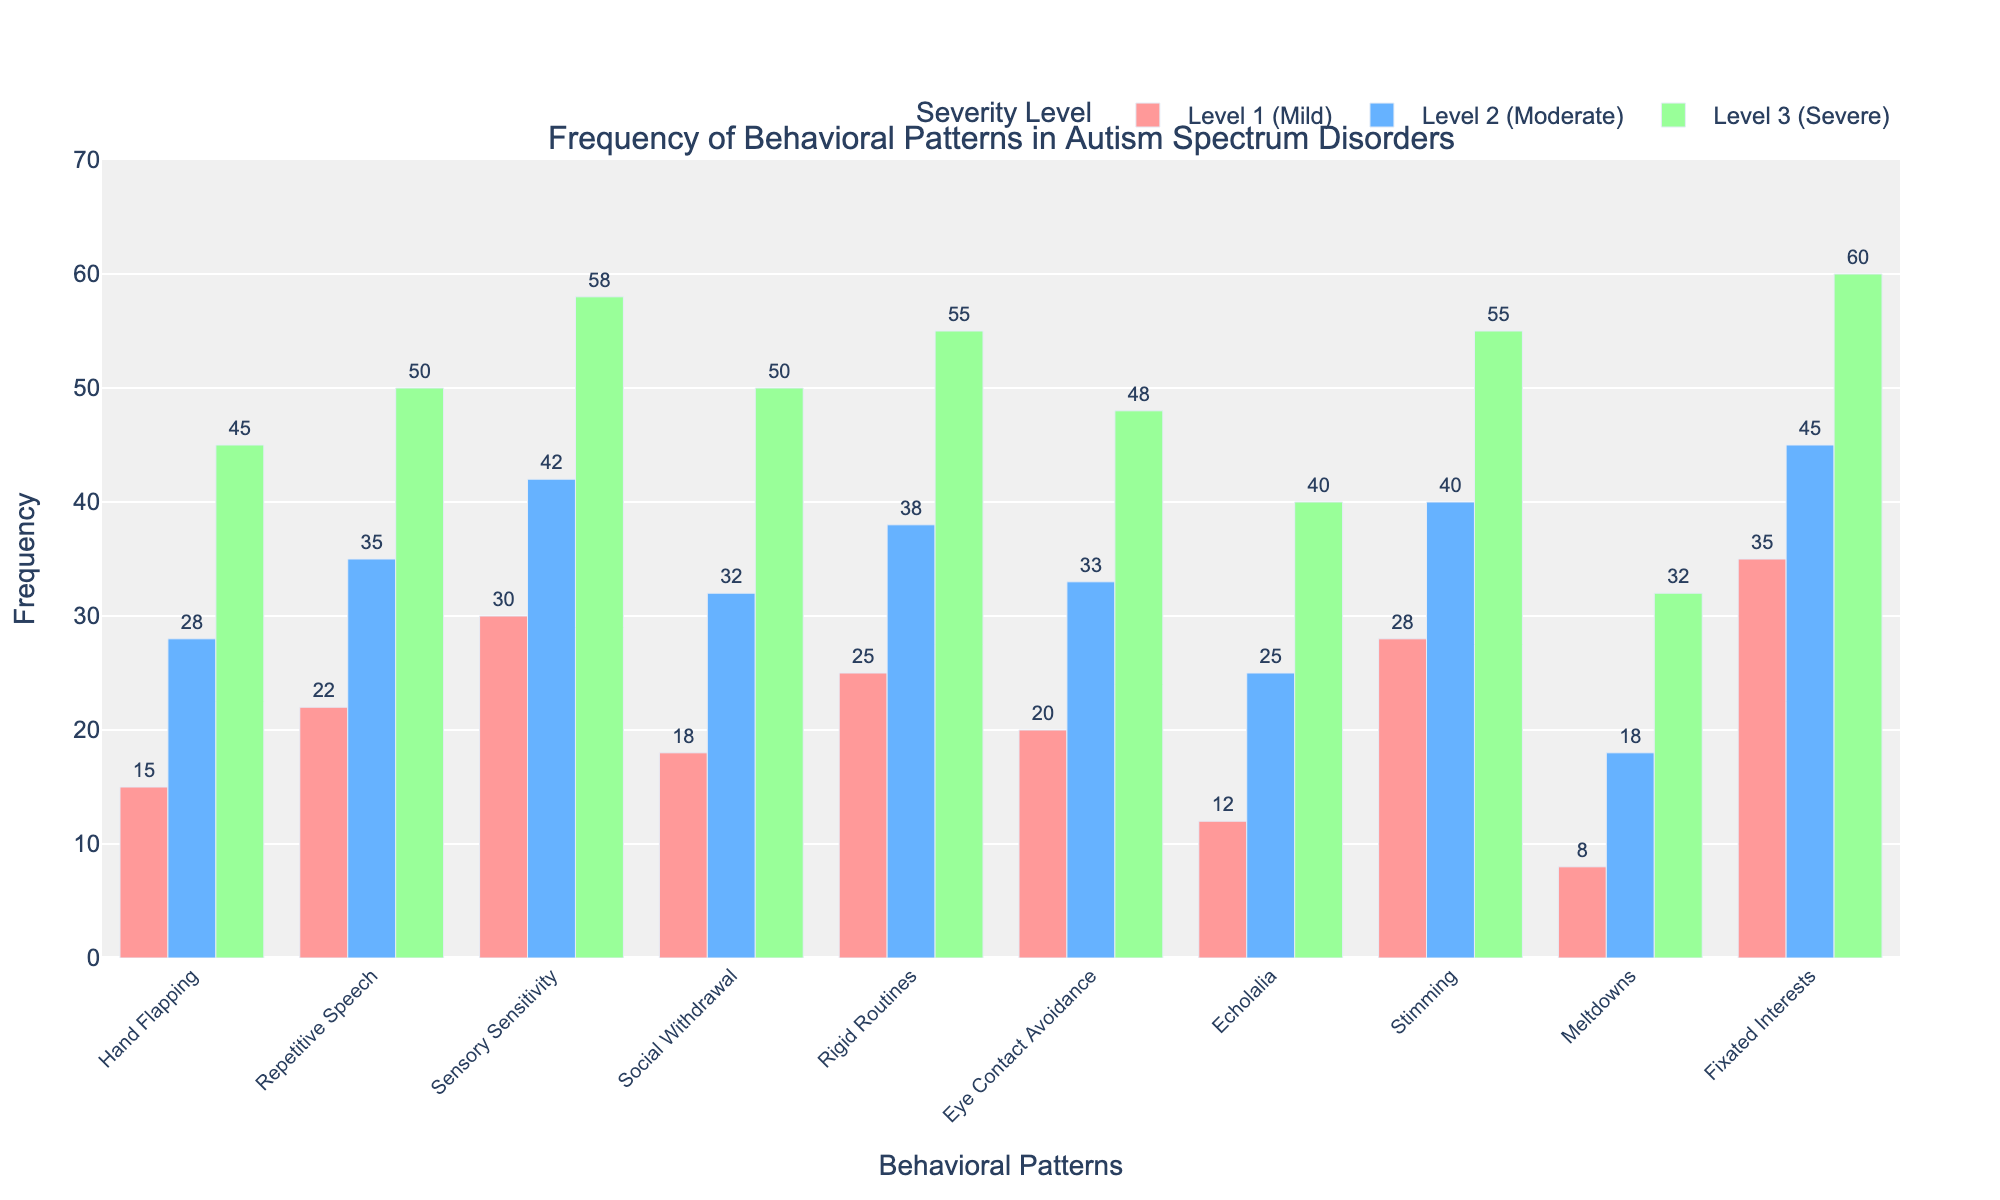What is the most frequent behavioral pattern observed at Level 2 (Moderate) severity? To find the most frequent behavioral pattern observed at Level 2, look at the highest value in the bar corresponding to "Level 2 (Moderate)." The highest bar is at 45 for "Fixated Interests."
Answer: Fixated Interests How much more frequent is "Social Withdrawal" in Level 3 (Severe) compared to Level 1 (Mild)? To find the difference, subtract the frequency of "Social Withdrawal" at Level 1 (18) from its frequency at Level 3 (50). The difference is 50 - 18 = 32.
Answer: 32 Which severity level has the highest frequency of "Echolalia"? Look at the bars corresponding to "Echolalia" for each severity level. The highest bar is at 40 for Level 3 (Severe).
Answer: Level 3 What's the average frequency of "Hand Flapping" across all severity levels? First, sum the frequencies for "Hand Flapping" across all levels: 15 (Mild) + 28 (Moderate) + 45 (Severe) = 88. Then, divide by the total number of levels (3): 88 / 3 ≈ 29.33.
Answer: 29.33 By how much does "Rigid Routines" differ between Level 2 (Moderate) and Level 3 (Severe)? To find the difference, subtract the frequency of "Rigid Routines" at Level 2 (38) from its frequency at Level 3 (55). The difference is 55 - 38 = 17.
Answer: 17 Which behavioral pattern shows the least difference in frequency between Level 1 (Mild) and Level 2 (Moderate)? Compare the differences for all patterns between Level 1 and Level 2, then find the smallest difference. "Echolalia" has the smallest difference: 25 - 12 = 13.
Answer: Echolalia What is the total frequency of "Stimming" observed across all severity levels? Add up the frequencies of "Stimming" for all levels: 28 (Mild) + 40 (Moderate) + 55 (Severe) = 123.
Answer: 123 Is "Meltdowns" more frequent in Level 2 (Moderate) or Level 1 (Mild)? Compare the heights of the bars for "Meltdowns" between Level 2 (Moderate) and Level 1 (Mild). The bar for Level 2 is higher at 18 compared to 8 for Level 1.
Answer: Level 2 How does the frequency of "Repetitive Speech" at Level 3 (Severe) compare to the combined frequency at Level 1 (Mild) and Level 2 (Moderate)? First, sum the frequencies of "Repetitive Speech" for Level 1 (22) and Level 2 (35): 22 + 35 = 57. Then, compare this to the frequency at Level 3 (50). Since 50 is less than 57, Level 3 is lower.
Answer: Lower 